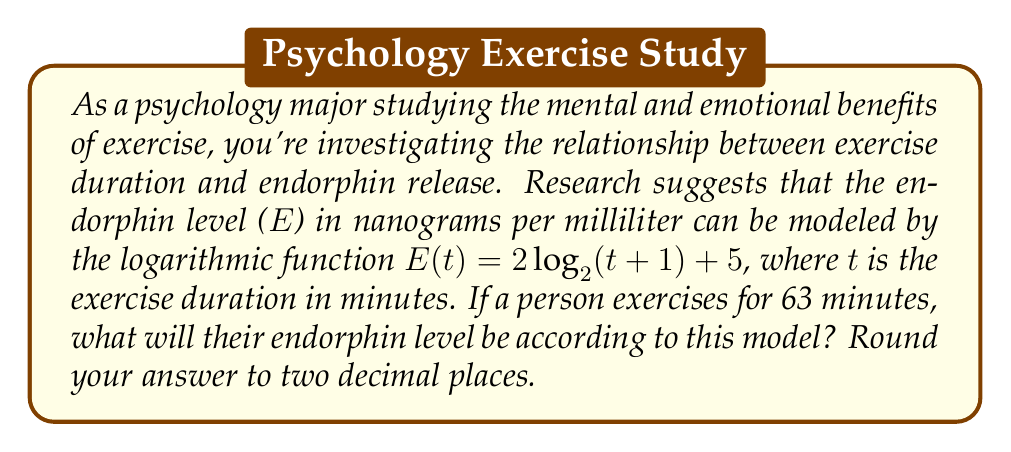Can you answer this question? To solve this problem, we need to use the given logarithmic function and substitute the exercise duration into the equation. Let's break it down step-by-step:

1) The given function is:
   $E(t) = 2\log_2(t+1) + 5$

2) We need to find E(63), so let's substitute t = 63:
   $E(63) = 2\log_2(63+1) + 5$

3) Simplify inside the parentheses:
   $E(63) = 2\log_2(64) + 5$

4) Now, we need to calculate $\log_2(64)$:
   $2^6 = 64$, so $\log_2(64) = 6$

5) Substitute this value:
   $E(63) = 2(6) + 5$

6) Calculate:
   $E(63) = 12 + 5 = 17$

Therefore, the endorphin level after 63 minutes of exercise would be 17 nanograms per milliliter.
Answer: $17.00$ ng/mL 